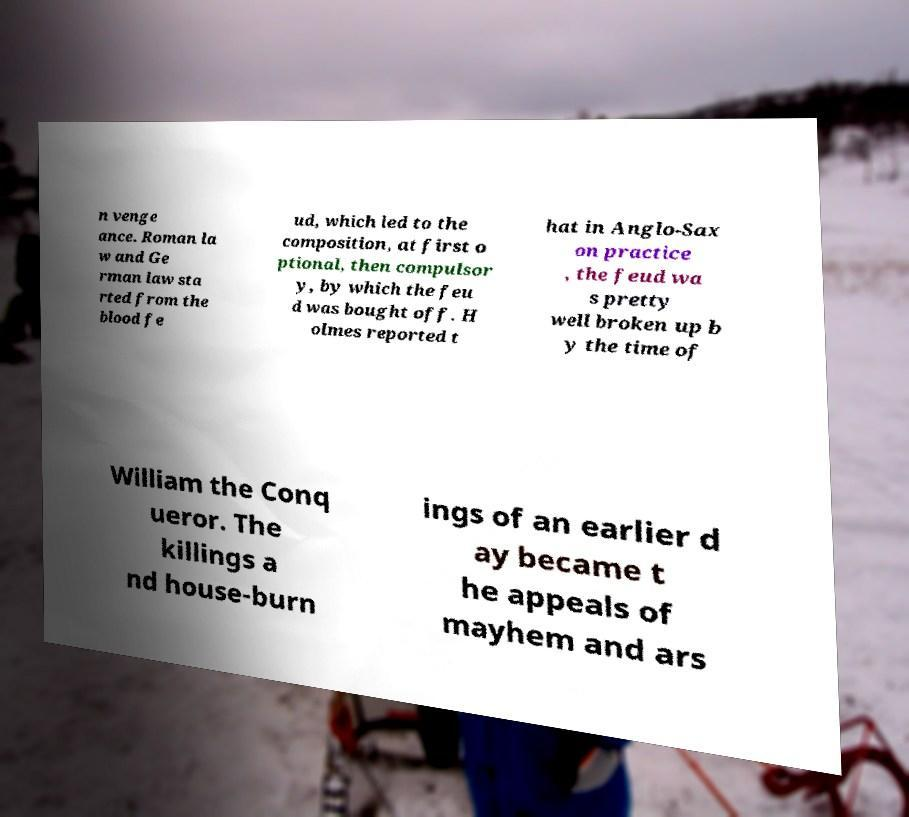Can you accurately transcribe the text from the provided image for me? n venge ance. Roman la w and Ge rman law sta rted from the blood fe ud, which led to the composition, at first o ptional, then compulsor y, by which the feu d was bought off. H olmes reported t hat in Anglo-Sax on practice , the feud wa s pretty well broken up b y the time of William the Conq ueror. The killings a nd house-burn ings of an earlier d ay became t he appeals of mayhem and ars 